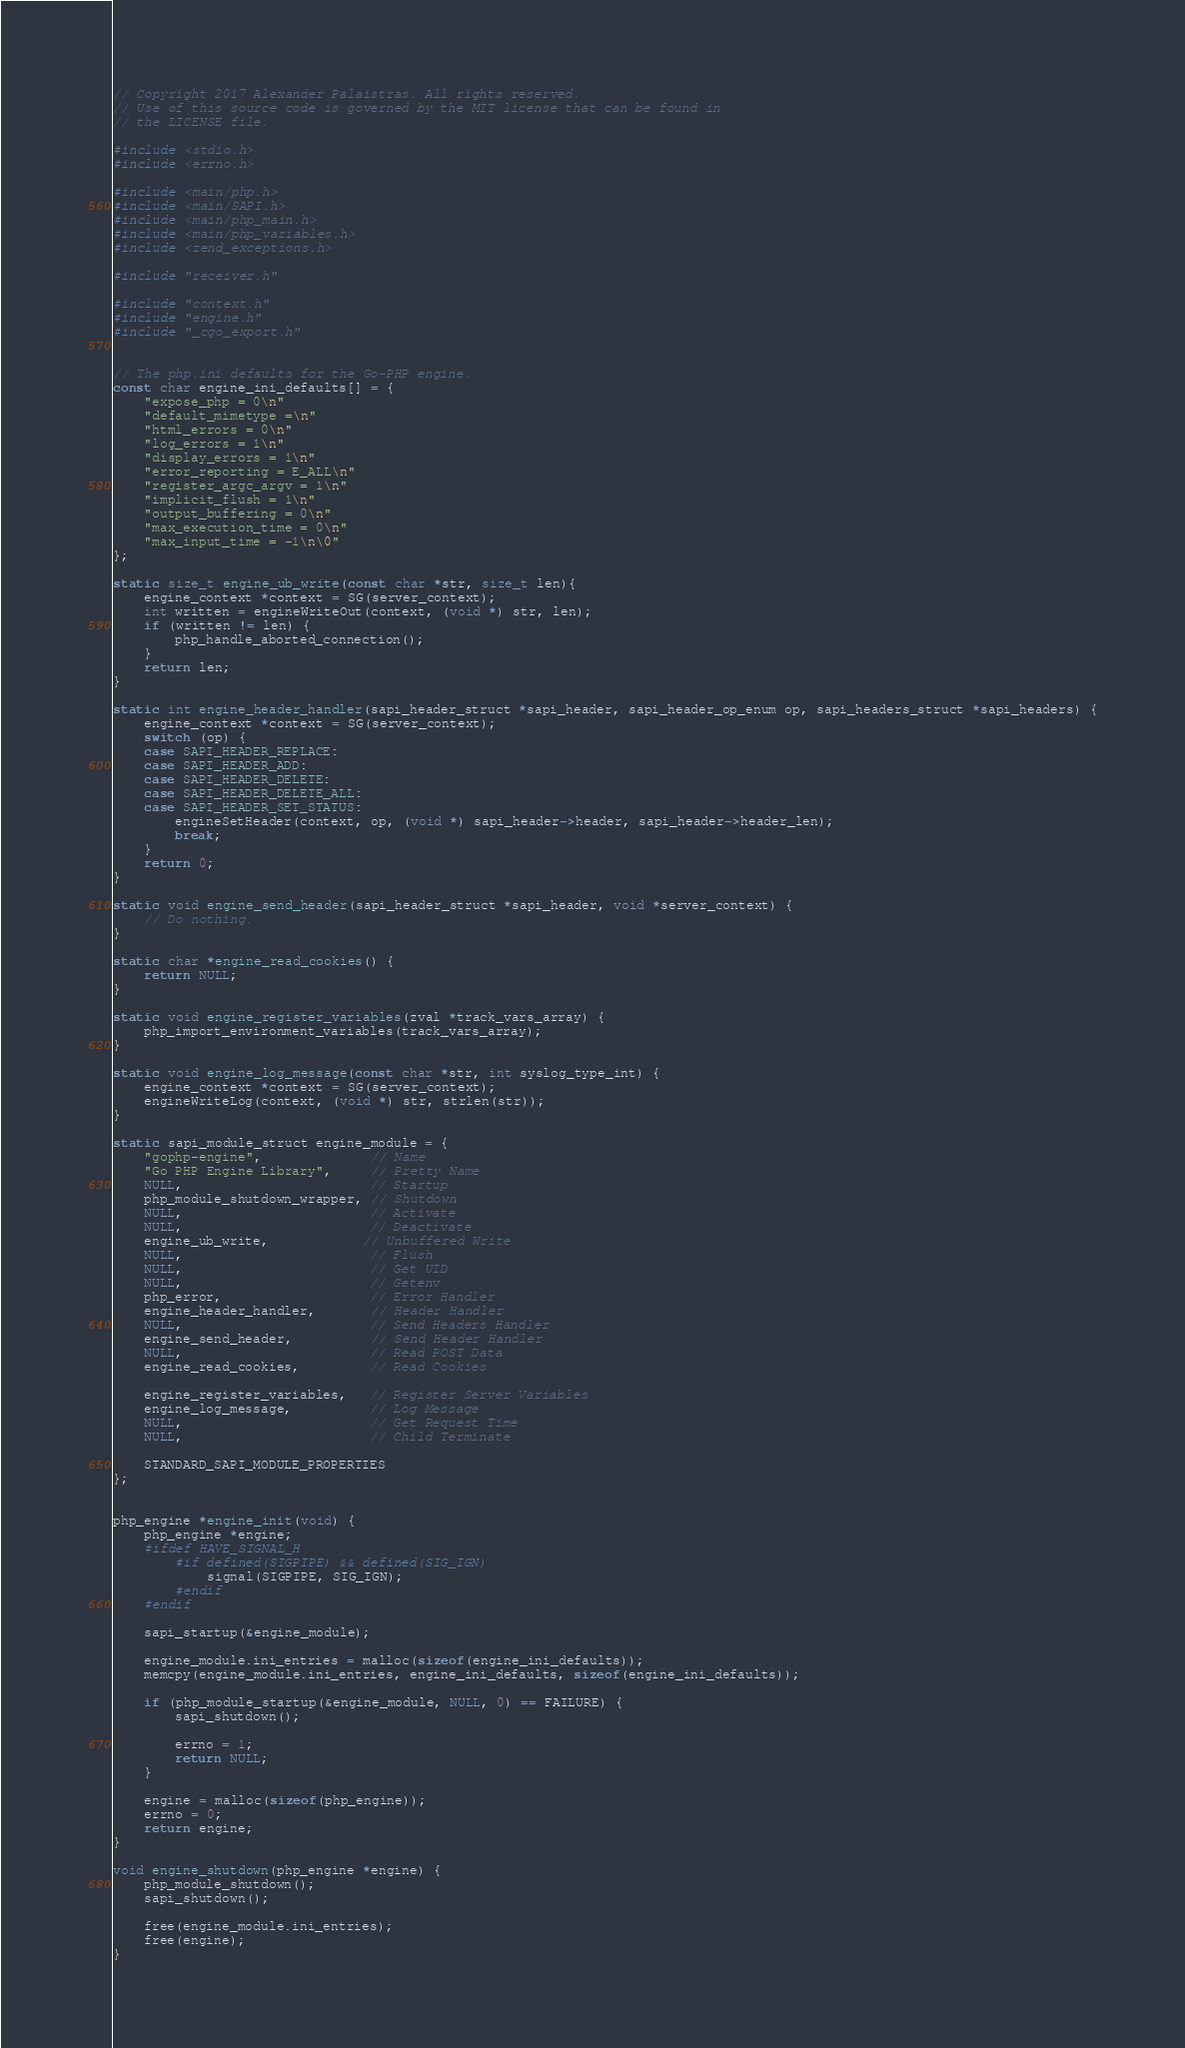<code> <loc_0><loc_0><loc_500><loc_500><_C_>// Copyright 2017 Alexander Palaistras. All rights reserved.
// Use of this source code is governed by the MIT license that can be found in
// the LICENSE file.

#include <stdio.h>
#include <errno.h>

#include <main/php.h>
#include <main/SAPI.h>
#include <main/php_main.h>
#include <main/php_variables.h>
#include <zend_exceptions.h>

#include "receiver.h"

#include "context.h"
#include "engine.h"
#include "_cgo_export.h"


// The php.ini defaults for the Go-PHP engine.
const char engine_ini_defaults[] = {
	"expose_php = 0\n"
	"default_mimetype =\n"
	"html_errors = 0\n"
	"log_errors = 1\n"
	"display_errors = 1\n"
	"error_reporting = E_ALL\n"
	"register_argc_argv = 1\n"
	"implicit_flush = 1\n"
	"output_buffering = 0\n"
	"max_execution_time = 0\n"
	"max_input_time = -1\n\0"
};

static size_t engine_ub_write(const char *str, size_t len){
	engine_context *context = SG(server_context);
	int written = engineWriteOut(context, (void *) str, len);
	if (written != len) {
		php_handle_aborted_connection();
	}
	return len;
}

static int engine_header_handler(sapi_header_struct *sapi_header, sapi_header_op_enum op, sapi_headers_struct *sapi_headers) {
	engine_context *context = SG(server_context);
	switch (op) {
	case SAPI_HEADER_REPLACE:
	case SAPI_HEADER_ADD:
	case SAPI_HEADER_DELETE:
	case SAPI_HEADER_DELETE_ALL:
	case SAPI_HEADER_SET_STATUS:
		engineSetHeader(context, op, (void *) sapi_header->header, sapi_header->header_len);
		break;
	}
	return 0;
}

static void engine_send_header(sapi_header_struct *sapi_header, void *server_context) {
	// Do nothing.
}

static char *engine_read_cookies() {
	return NULL;
}

static void engine_register_variables(zval *track_vars_array) {
	php_import_environment_variables(track_vars_array);
}

static void engine_log_message(const char *str, int syslog_type_int) {
	engine_context *context = SG(server_context);
	engineWriteLog(context, (void *) str, strlen(str));
}

static sapi_module_struct engine_module = {
	"gophp-engine",              // Name
	"Go PHP Engine Library",     // Pretty Name
	NULL,                        // Startup
	php_module_shutdown_wrapper, // Shutdown
	NULL,                        // Activate
	NULL,                        // Deactivate
	engine_ub_write,            // Unbuffered Write
	NULL,                        // Flush
	NULL,                        // Get UID
	NULL,                        // Getenv
	php_error,                   // Error Handler
	engine_header_handler,       // Header Handler
	NULL,                        // Send Headers Handler
	engine_send_header,          // Send Header Handler
	NULL,                        // Read POST Data
	engine_read_cookies,         // Read Cookies

	engine_register_variables,   // Register Server Variables
	engine_log_message,          // Log Message
	NULL,                        // Get Request Time
	NULL,                        // Child Terminate

	STANDARD_SAPI_MODULE_PROPERTIES
};


php_engine *engine_init(void) {
	php_engine *engine;
	#ifdef HAVE_SIGNAL_H
		#if defined(SIGPIPE) && defined(SIG_IGN)
			signal(SIGPIPE, SIG_IGN);
		#endif
	#endif

	sapi_startup(&engine_module);

	engine_module.ini_entries = malloc(sizeof(engine_ini_defaults));
	memcpy(engine_module.ini_entries, engine_ini_defaults, sizeof(engine_ini_defaults));

	if (php_module_startup(&engine_module, NULL, 0) == FAILURE) {
		sapi_shutdown();

		errno = 1;
		return NULL;
	}

	engine = malloc(sizeof(php_engine));
	errno = 0;
	return engine;
}

void engine_shutdown(php_engine *engine) {
	php_module_shutdown();
	sapi_shutdown();

	free(engine_module.ini_entries);
	free(engine);
}
</code> 